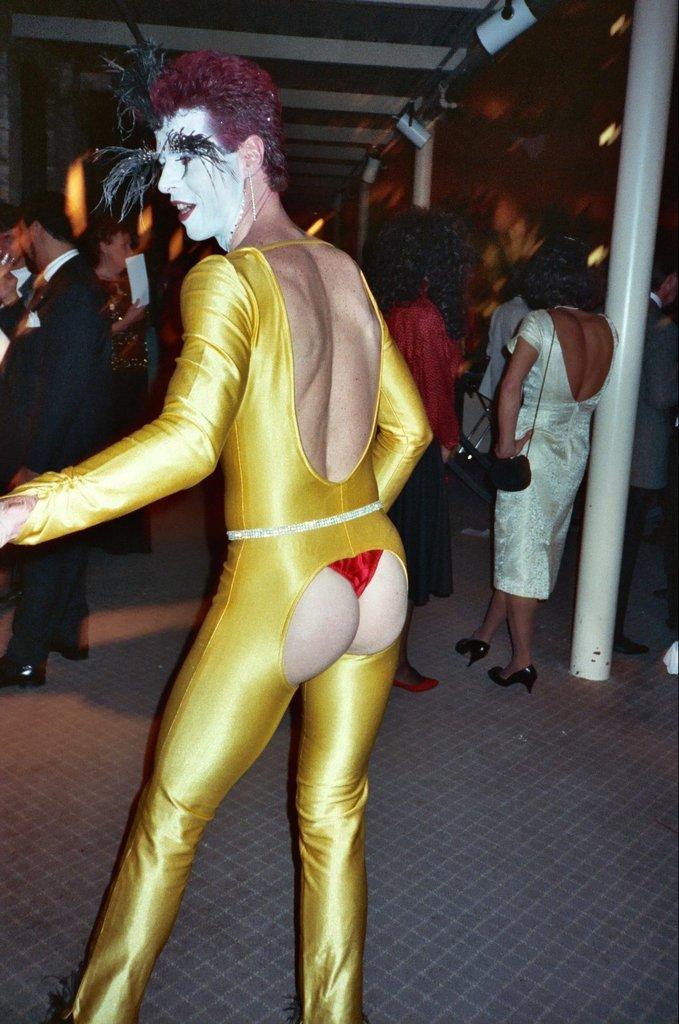How would you summarize this image in a sentence or two? The woman in the yellow dress is standing in front of the picture. In front of her, we see people standing. The girl in the black dress is holding papers in her hands. On the right side, the woman in white dress is standing beside the white pole. In the background, we see a brown color wall. At the top of the picture, we see the ceiling of the room. 